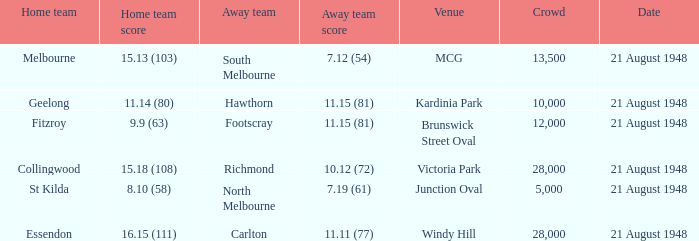With a home team score of 15.18 (108), what was the smallest crowd size recorded? 28000.0. 